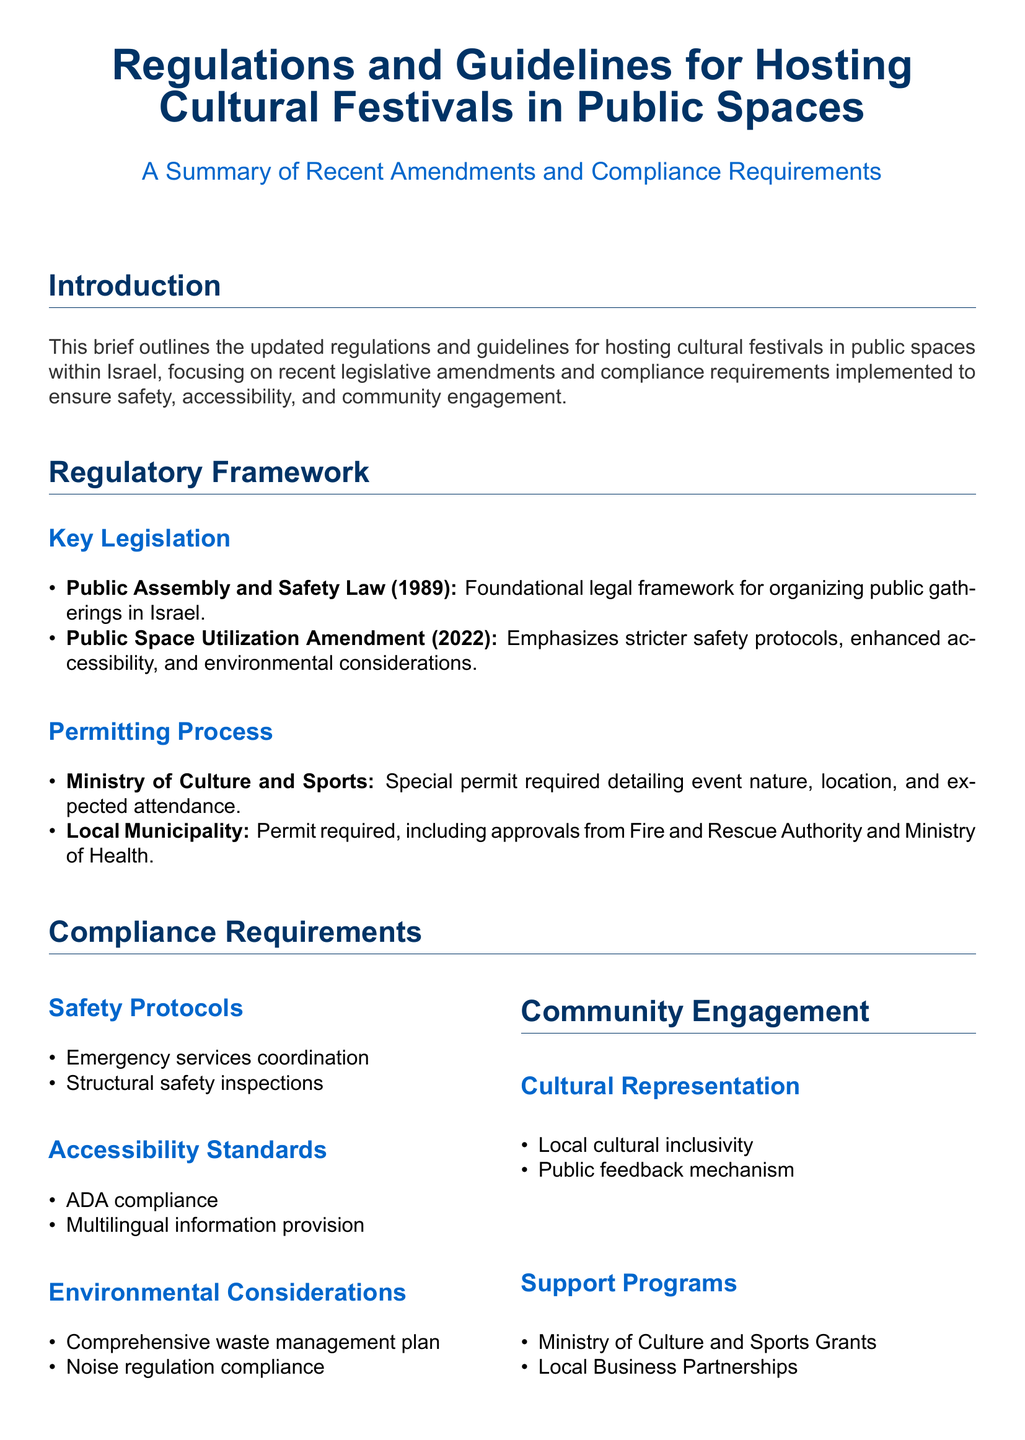what is the foundational legal framework for organizing public gatherings in Israel? The document specifies that the Public Assembly and Safety Law (1989) is the foundational legal framework for this purpose.
Answer: Public Assembly and Safety Law (1989) what year was the Public Space Utilization Amendment implemented? The document mentions that the Public Space Utilization Amendment was implemented in 2022.
Answer: 2022 which authority's approval is required for permits from local municipalities? According to the document, the approvals from the Fire and Rescue Authority and Ministry of Health are required.
Answer: Fire and Rescue Authority and Ministry of Health what is one of the safety protocols mentioned in the compliance requirements? The document lists emergency services coordination and structural safety inspections as safety protocols.
Answer: Emergency services coordination what type of inclusivity is required for cultural representation at festivals? The document emphasizes local cultural inclusivity as a requirement for cultural representation at festivals.
Answer: Local cultural inclusivity what does ADA compliance refer to in the context of hosting cultural festivals? The document indicates that ADA compliance is part of the accessibility standards that need to be adhered to.
Answer: Accessibility standards how does the document suggest obtaining community feedback for events? The document mentions the establishment of a public feedback mechanism to obtain community feedback for events.
Answer: Public feedback mechanism what is emphasized as part of the environmental considerations? The document requires a comprehensive waste management plan and compliance with noise regulations under environmental considerations.
Answer: Comprehensive waste management plan which ministry offers grants for support programs related to cultural festivals? The document states that the Ministry of Culture and Sports offers grants for support programs related to cultural festivals.
Answer: Ministry of Culture and Sports 